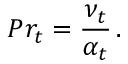Convert formula to latex. <formula><loc_0><loc_0><loc_500><loc_500>P r _ { t } = \frac { \nu _ { t } } { \alpha _ { t } } \, .</formula> 